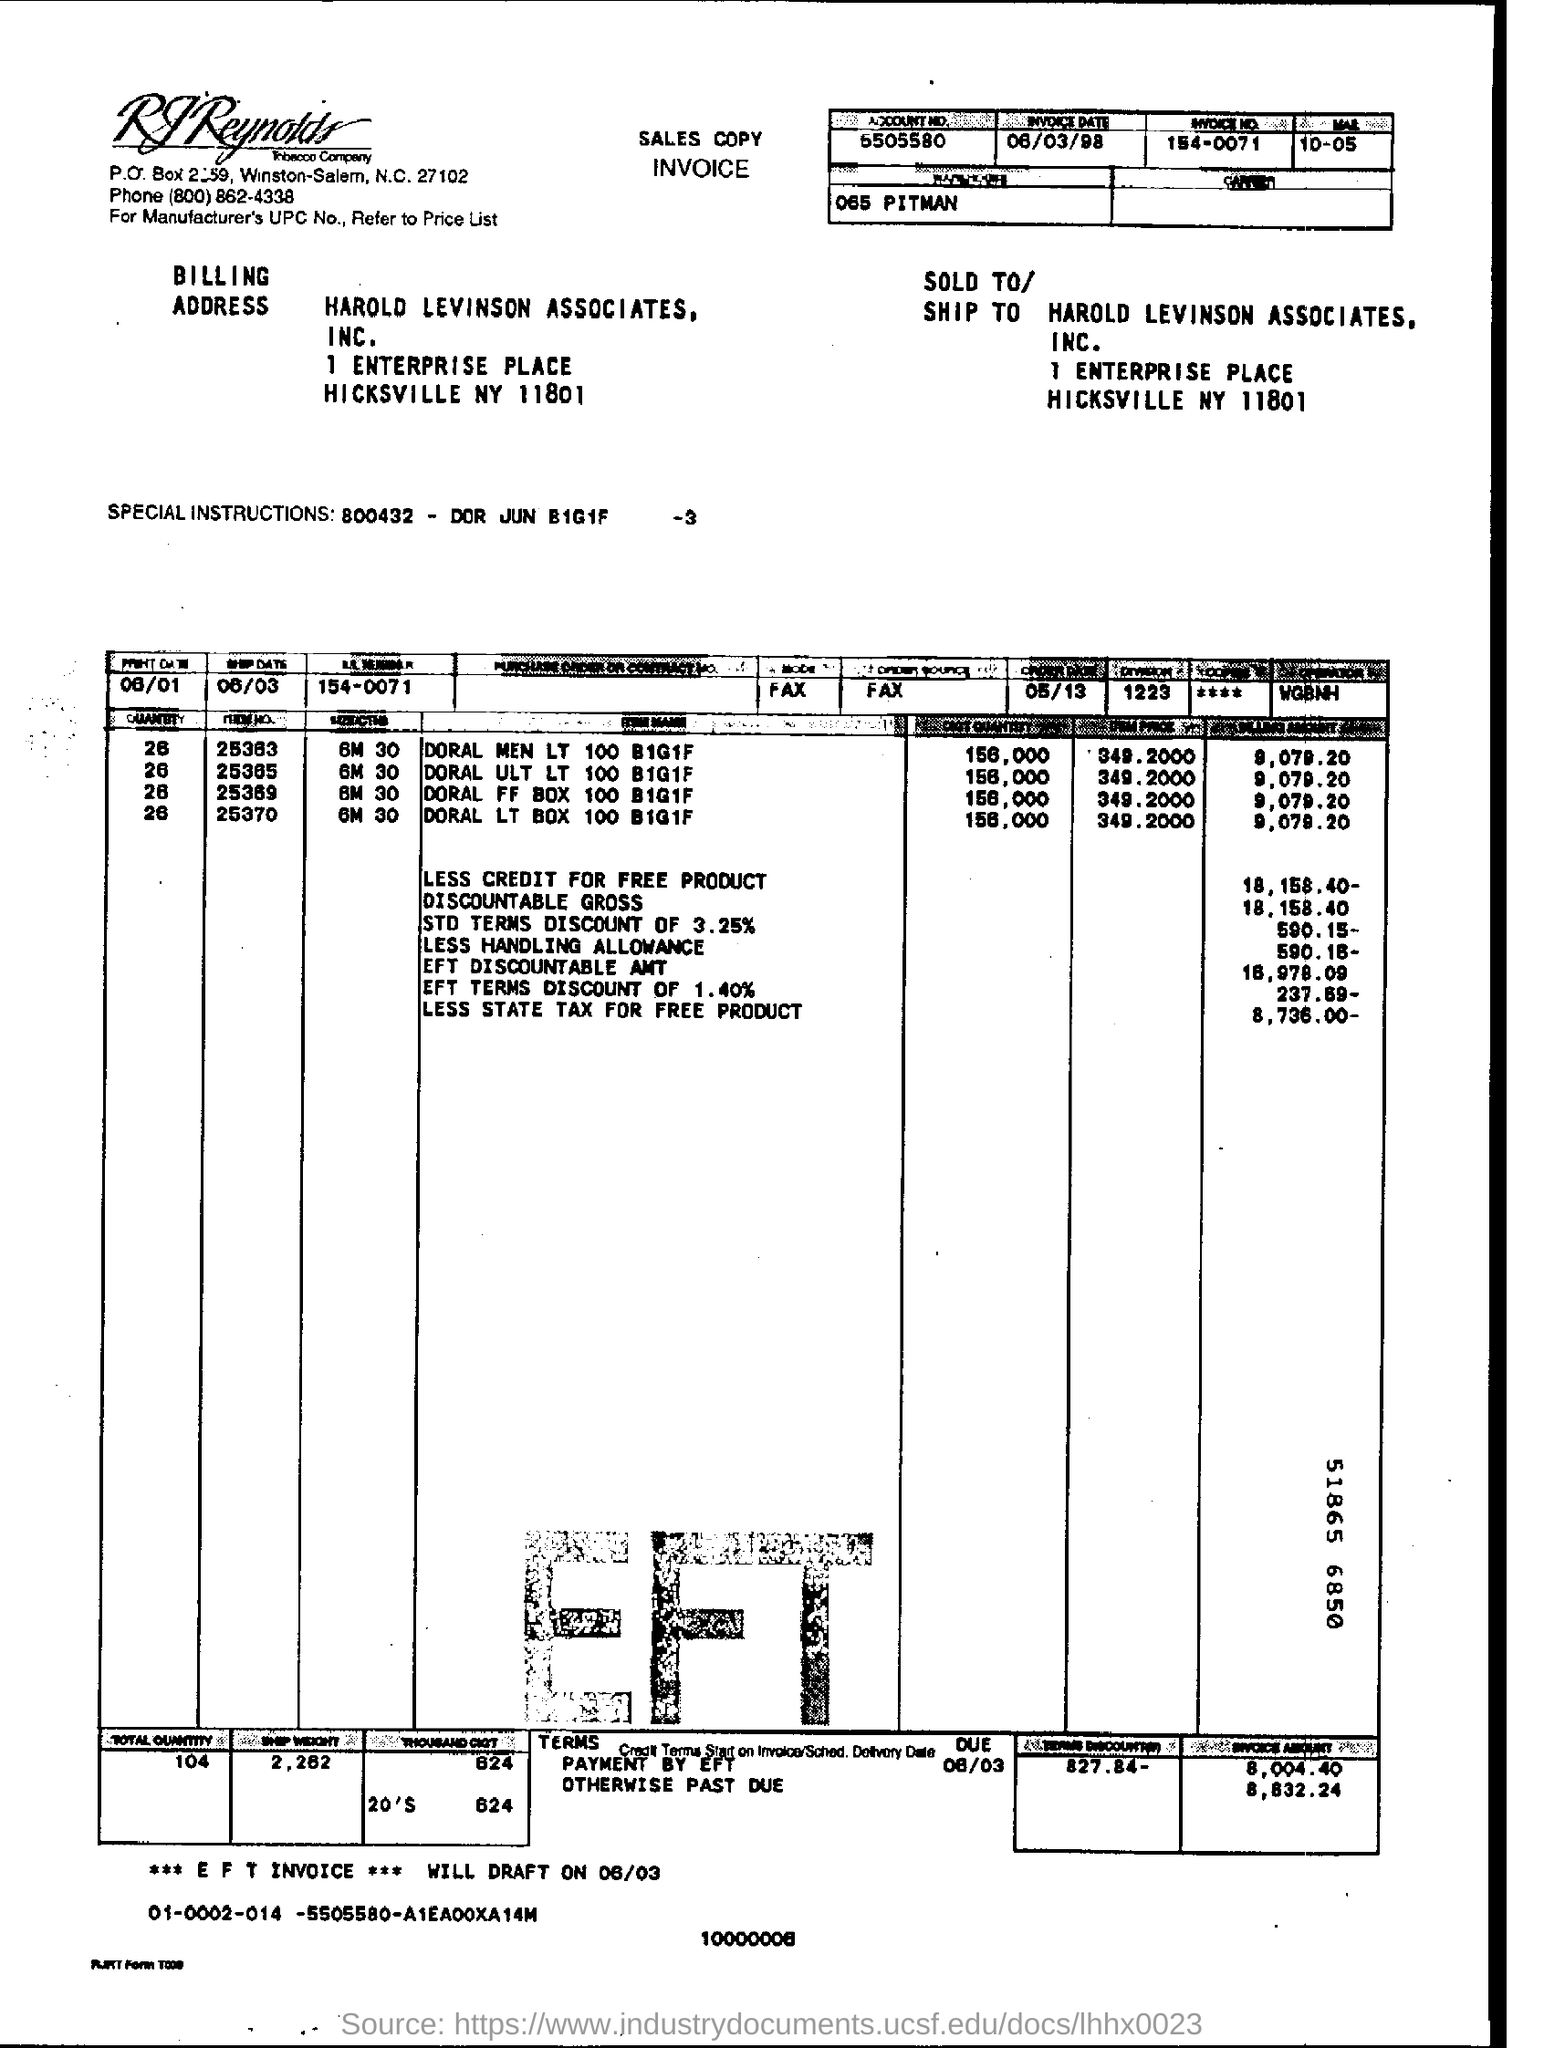To whom this is sold to ?
Provide a short and direct response. Harold Levinson Associates , INC. What is the invoice date ?
Your answer should be compact. 06/03/98. What is the total quantity ?
Offer a very short reply. 104. What is the ***eft invoice *** will draft on ?
Offer a very short reply. 06/03. 